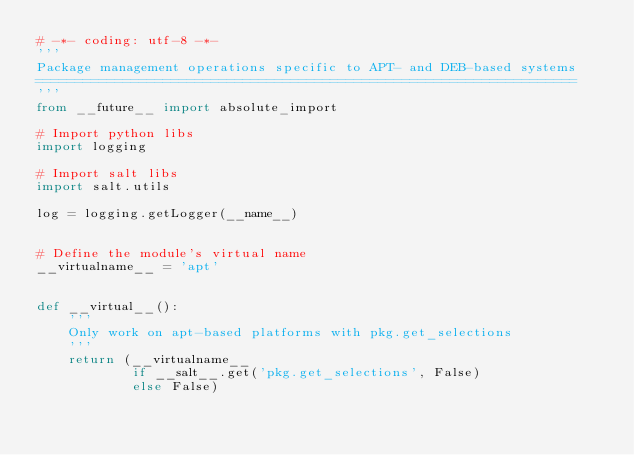Convert code to text. <code><loc_0><loc_0><loc_500><loc_500><_Python_># -*- coding: utf-8 -*-
'''
Package management operations specific to APT- and DEB-based systems
====================================================================
'''
from __future__ import absolute_import

# Import python libs
import logging

# Import salt libs
import salt.utils

log = logging.getLogger(__name__)


# Define the module's virtual name
__virtualname__ = 'apt'


def __virtual__():
    '''
    Only work on apt-based platforms with pkg.get_selections
    '''
    return (__virtualname__
            if __salt__.get('pkg.get_selections', False)
            else False)

</code> 